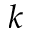<formula> <loc_0><loc_0><loc_500><loc_500>k</formula> 